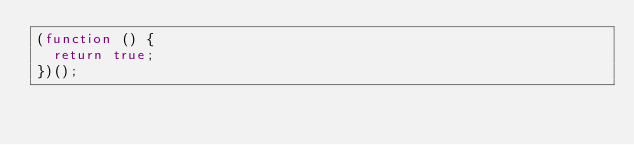Convert code to text. <code><loc_0><loc_0><loc_500><loc_500><_JavaScript_>(function () {
  return true;
})();

</code> 